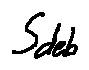<formula> <loc_0><loc_0><loc_500><loc_500>s _ { d e b }</formula> 